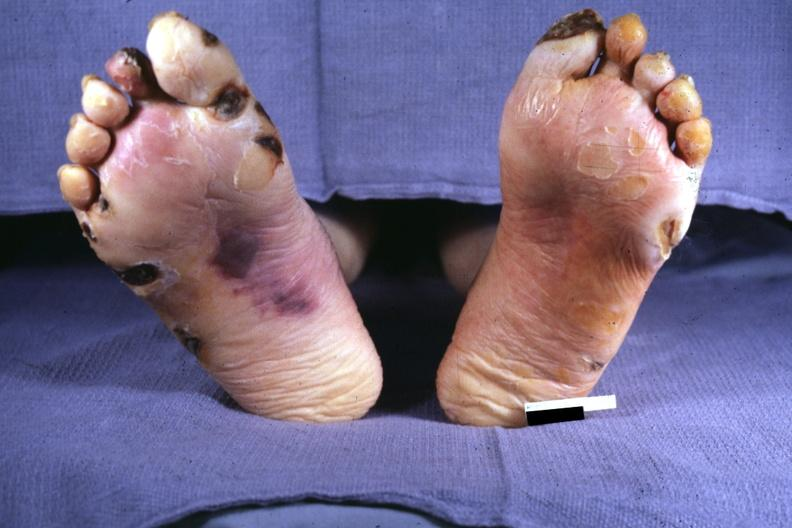re crookes cells present?
Answer the question using a single word or phrase. No 